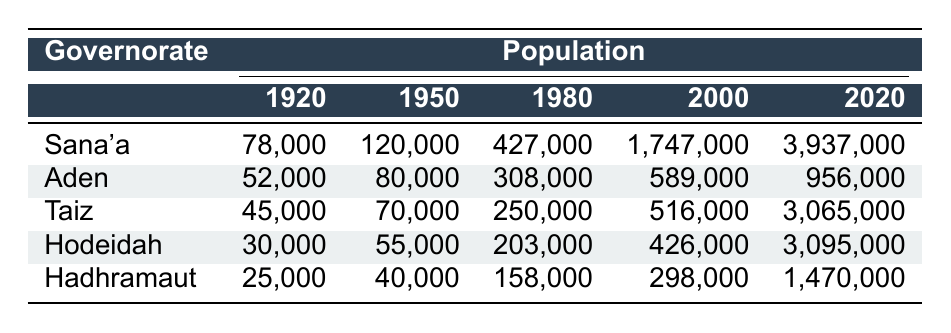What was the population of Sana'a in 1980? The table shows that the population of Sana'a in 1980 was listed as 427,000.
Answer: 427,000 Which governorate had the smallest population in 1920? By comparing the populations in the 1920 row, Hadhramaut, with a population of 25,000, had the smallest population among the listed governorates.
Answer: Hadhramaut What is the total population of Aden across all given years? Adding Aden's populations: 52,000 (1920) + 80,000 (1950) + 308,000 (1980) + 589,000 (2000) + 956,000 (2020) equals 1,985,000.
Answer: 1,985,000 Did Taiz's population grow more significantly from 2000 to 2020 compared to the growth of Aden in the same years? The population of Taiz increased from 516,000 in 2000 to 3,065,000 in 2020 (a growth of 2,549,000). Aden grew from 589,000 to 956,000 (a growth of 367,000). Taiz had a greater growth.
Answer: Yes What was the percentage increase in the population of Hodeidah from 1980 to 2020? The population of Hodeidah increased from 203,000 in 1980 to 3,095,000 in 2020. The increase is 3,095,000 - 203,000 = 2,892,000. To find the percentage increase: (2,892,000 / 203,000) * 100 ≈ 1423.17%.
Answer: Approximately 1423.17% Which governorate had the highest population in 2000, and by how much did it exceed the population of Hadhramaut in the same year? In 2000, Sana'a had the highest population at 1,747,000, while Hadhramaut had a population of 298,000. The difference is 1,747,000 - 298,000 = 1,449,000.
Answer: Sana'a; 1,449,000 Is the population of Hadhramaut in 2020 lower than that of Aden in 1950? In 2020, Hadhramaut had a population of 1,470,000, while Aden in 1950 had a population of 80,000. Since 1,470,000 > 80,000, the statement is false.
Answer: No Which governorate has shown the most dramatic increase in population from 1920 to 2020? By comparing the populations, Sana'a grew from 78,000 in 1920 to 3,937,000 in 2020, an increase of 3,859,000. Taiz also showed significant growth, but Sana'a had the highest overall increase from the lowest to the highest year.
Answer: Sana'a What is the average population of Aden over the years listed? The populations for Aden are 52,000 (1920), 80,000 (1950), 308,000 (1980), 589,000 (2000), and 956,000 (2020). The total is 1,985,000, and dividing that by 5 gives an average of 397,000.
Answer: 397,000 